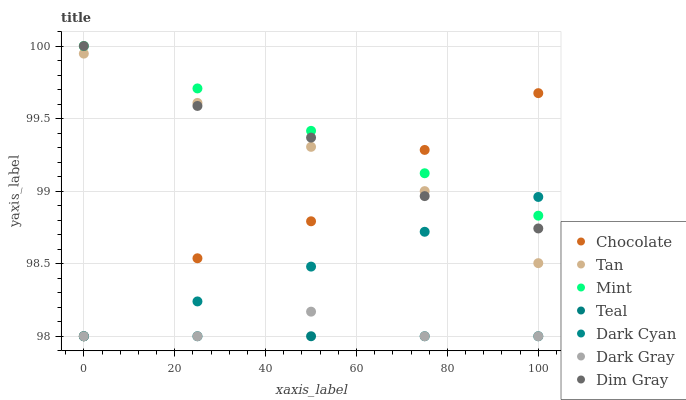Does Teal have the minimum area under the curve?
Answer yes or no. Yes. Does Mint have the maximum area under the curve?
Answer yes or no. Yes. Does Chocolate have the minimum area under the curve?
Answer yes or no. No. Does Chocolate have the maximum area under the curve?
Answer yes or no. No. Is Teal the smoothest?
Answer yes or no. Yes. Is Dark Gray the roughest?
Answer yes or no. Yes. Is Chocolate the smoothest?
Answer yes or no. No. Is Chocolate the roughest?
Answer yes or no. No. Does Chocolate have the lowest value?
Answer yes or no. Yes. Does Tan have the lowest value?
Answer yes or no. No. Does Mint have the highest value?
Answer yes or no. Yes. Does Chocolate have the highest value?
Answer yes or no. No. Is Teal less than Dim Gray?
Answer yes or no. Yes. Is Tan greater than Teal?
Answer yes or no. Yes. Does Teal intersect Dark Gray?
Answer yes or no. Yes. Is Teal less than Dark Gray?
Answer yes or no. No. Is Teal greater than Dark Gray?
Answer yes or no. No. Does Teal intersect Dim Gray?
Answer yes or no. No. 